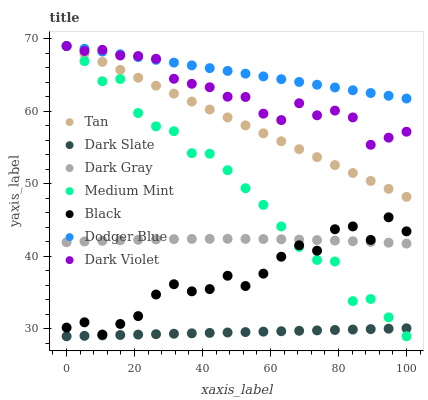Does Dark Slate have the minimum area under the curve?
Answer yes or no. Yes. Does Dodger Blue have the maximum area under the curve?
Answer yes or no. Yes. Does Dark Violet have the minimum area under the curve?
Answer yes or no. No. Does Dark Violet have the maximum area under the curve?
Answer yes or no. No. Is Dark Slate the smoothest?
Answer yes or no. Yes. Is Black the roughest?
Answer yes or no. Yes. Is Dark Violet the smoothest?
Answer yes or no. No. Is Dark Violet the roughest?
Answer yes or no. No. Does Medium Mint have the lowest value?
Answer yes or no. Yes. Does Dark Violet have the lowest value?
Answer yes or no. No. Does Tan have the highest value?
Answer yes or no. Yes. Does Dark Gray have the highest value?
Answer yes or no. No. Is Dark Slate less than Dark Violet?
Answer yes or no. Yes. Is Dodger Blue greater than Black?
Answer yes or no. Yes. Does Medium Mint intersect Tan?
Answer yes or no. Yes. Is Medium Mint less than Tan?
Answer yes or no. No. Is Medium Mint greater than Tan?
Answer yes or no. No. Does Dark Slate intersect Dark Violet?
Answer yes or no. No. 